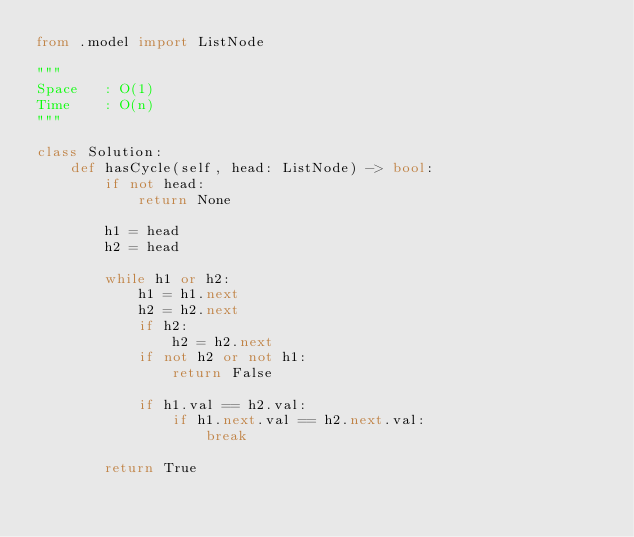Convert code to text. <code><loc_0><loc_0><loc_500><loc_500><_Python_>from .model import ListNode

"""
Space   : O(1)
Time    : O(n)
"""

class Solution:
    def hasCycle(self, head: ListNode) -> bool:
        if not head:
            return None

        h1 = head
        h2 = head

        while h1 or h2:
            h1 = h1.next
            h2 = h2.next
            if h2:
                h2 = h2.next
            if not h2 or not h1:
                return False

            if h1.val == h2.val:
                if h1.next.val == h2.next.val:
                    break

        return True
</code> 